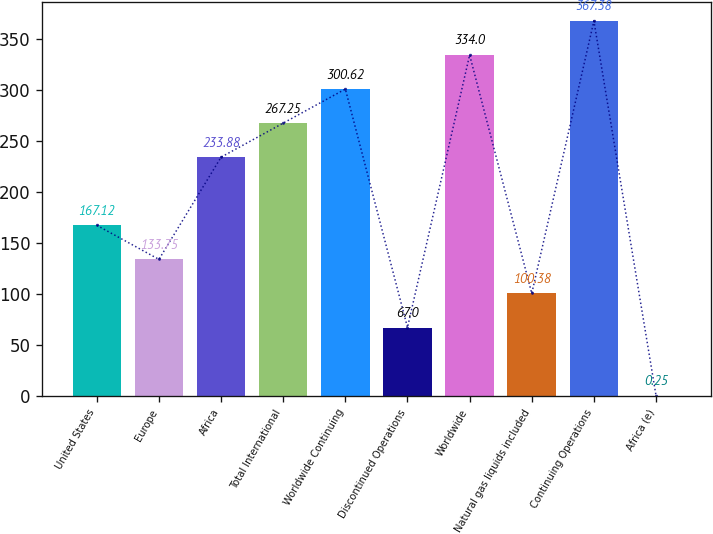Convert chart. <chart><loc_0><loc_0><loc_500><loc_500><bar_chart><fcel>United States<fcel>Europe<fcel>Africa<fcel>Total International<fcel>Worldwide Continuing<fcel>Discontinued Operations<fcel>Worldwide<fcel>Natural gas liquids included<fcel>Continuing Operations<fcel>Africa (e)<nl><fcel>167.12<fcel>133.75<fcel>233.88<fcel>267.25<fcel>300.62<fcel>67<fcel>334<fcel>100.38<fcel>367.38<fcel>0.25<nl></chart> 